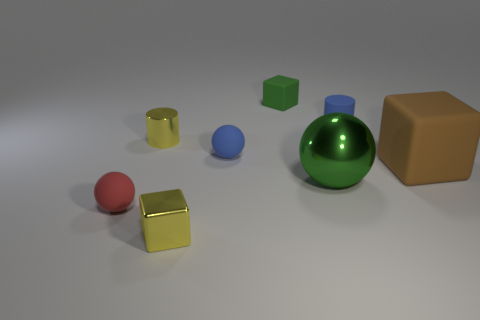There is another red thing that is the same shape as the big metal object; what material is it?
Your response must be concise. Rubber. Are there the same number of big matte objects that are behind the blue matte ball and shiny cubes?
Make the answer very short. No. There is a object that is to the left of the green metal thing and behind the yellow cylinder; what is its size?
Ensure brevity in your answer.  Small. Is there anything else that has the same color as the large rubber object?
Your answer should be compact. No. What size is the red thing that is behind the cube left of the small blue matte sphere?
Offer a terse response. Small. There is a small rubber thing that is in front of the metallic cylinder and to the right of the small yellow metal block; what is its color?
Make the answer very short. Blue. How many other objects are the same size as the red rubber ball?
Your answer should be very brief. 5. There is a blue cylinder; is its size the same as the rubber ball that is left of the tiny shiny cylinder?
Give a very brief answer. Yes. What color is the matte cylinder that is the same size as the red matte object?
Provide a succinct answer. Blue. How big is the yellow block?
Ensure brevity in your answer.  Small. 